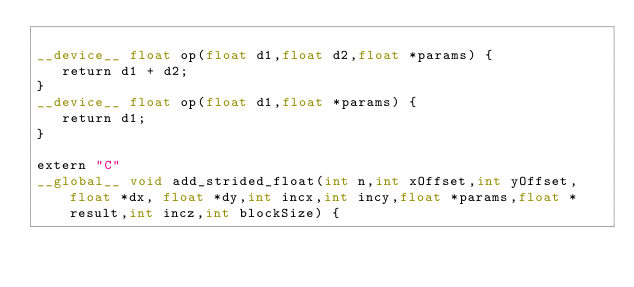Convert code to text. <code><loc_0><loc_0><loc_500><loc_500><_Cuda_>
__device__ float op(float d1,float d2,float *params) {
   return d1 + d2;
}
__device__ float op(float d1,float *params) {
   return d1;
}

extern "C"
__global__ void add_strided_float(int n,int xOffset,int yOffset, float *dx, float *dy,int incx,int incy,float *params,float *result,int incz,int blockSize) {</code> 